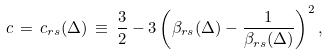<formula> <loc_0><loc_0><loc_500><loc_500>c \, = \, c _ { r s } ( \Delta ) \, \equiv \, \frac { 3 } { 2 } - 3 \left ( \beta _ { r s } ( \Delta ) - \frac { 1 } { \beta _ { r s } ( \Delta ) } \right ) ^ { 2 } ,</formula> 